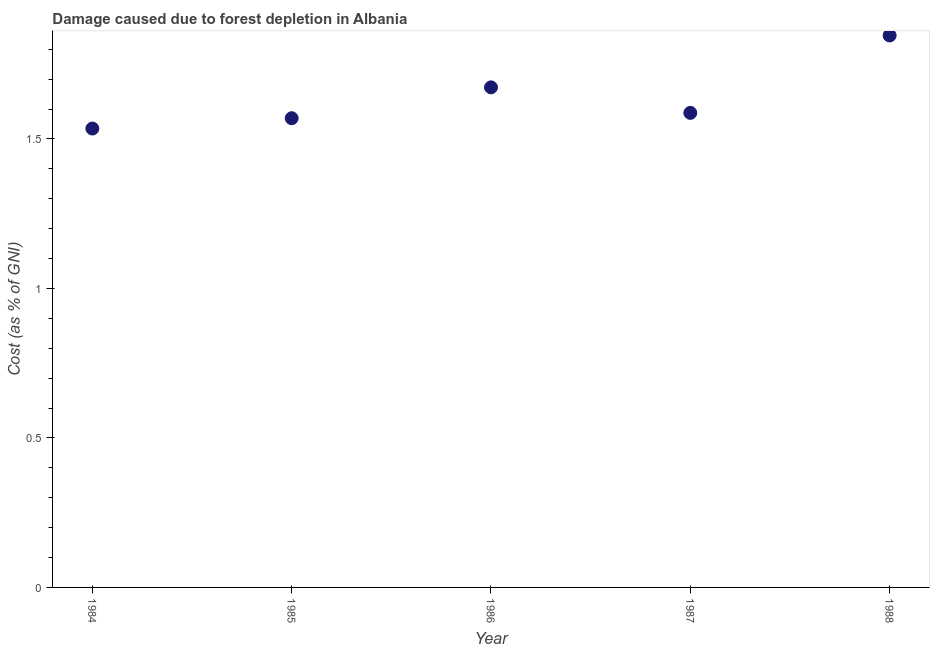What is the damage caused due to forest depletion in 1987?
Your answer should be very brief. 1.59. Across all years, what is the maximum damage caused due to forest depletion?
Offer a terse response. 1.85. Across all years, what is the minimum damage caused due to forest depletion?
Your answer should be compact. 1.53. What is the sum of the damage caused due to forest depletion?
Ensure brevity in your answer.  8.21. What is the difference between the damage caused due to forest depletion in 1985 and 1986?
Make the answer very short. -0.1. What is the average damage caused due to forest depletion per year?
Make the answer very short. 1.64. What is the median damage caused due to forest depletion?
Your answer should be compact. 1.59. Do a majority of the years between 1987 and 1988 (inclusive) have damage caused due to forest depletion greater than 0.7 %?
Keep it short and to the point. Yes. What is the ratio of the damage caused due to forest depletion in 1985 to that in 1988?
Ensure brevity in your answer.  0.85. Is the damage caused due to forest depletion in 1984 less than that in 1986?
Make the answer very short. Yes. What is the difference between the highest and the second highest damage caused due to forest depletion?
Provide a succinct answer. 0.17. What is the difference between the highest and the lowest damage caused due to forest depletion?
Offer a very short reply. 0.31. Does the damage caused due to forest depletion monotonically increase over the years?
Offer a very short reply. No. How many years are there in the graph?
Make the answer very short. 5. Are the values on the major ticks of Y-axis written in scientific E-notation?
Provide a succinct answer. No. Does the graph contain grids?
Keep it short and to the point. No. What is the title of the graph?
Keep it short and to the point. Damage caused due to forest depletion in Albania. What is the label or title of the X-axis?
Offer a very short reply. Year. What is the label or title of the Y-axis?
Give a very brief answer. Cost (as % of GNI). What is the Cost (as % of GNI) in 1984?
Offer a terse response. 1.53. What is the Cost (as % of GNI) in 1985?
Your response must be concise. 1.57. What is the Cost (as % of GNI) in 1986?
Ensure brevity in your answer.  1.67. What is the Cost (as % of GNI) in 1987?
Offer a very short reply. 1.59. What is the Cost (as % of GNI) in 1988?
Offer a very short reply. 1.85. What is the difference between the Cost (as % of GNI) in 1984 and 1985?
Keep it short and to the point. -0.03. What is the difference between the Cost (as % of GNI) in 1984 and 1986?
Your answer should be very brief. -0.14. What is the difference between the Cost (as % of GNI) in 1984 and 1987?
Give a very brief answer. -0.05. What is the difference between the Cost (as % of GNI) in 1984 and 1988?
Give a very brief answer. -0.31. What is the difference between the Cost (as % of GNI) in 1985 and 1986?
Your response must be concise. -0.1. What is the difference between the Cost (as % of GNI) in 1985 and 1987?
Your answer should be very brief. -0.02. What is the difference between the Cost (as % of GNI) in 1985 and 1988?
Your answer should be very brief. -0.28. What is the difference between the Cost (as % of GNI) in 1986 and 1987?
Keep it short and to the point. 0.09. What is the difference between the Cost (as % of GNI) in 1986 and 1988?
Your answer should be compact. -0.17. What is the difference between the Cost (as % of GNI) in 1987 and 1988?
Keep it short and to the point. -0.26. What is the ratio of the Cost (as % of GNI) in 1984 to that in 1985?
Provide a succinct answer. 0.98. What is the ratio of the Cost (as % of GNI) in 1984 to that in 1986?
Your answer should be compact. 0.92. What is the ratio of the Cost (as % of GNI) in 1984 to that in 1987?
Your response must be concise. 0.97. What is the ratio of the Cost (as % of GNI) in 1984 to that in 1988?
Your answer should be very brief. 0.83. What is the ratio of the Cost (as % of GNI) in 1985 to that in 1986?
Your answer should be very brief. 0.94. What is the ratio of the Cost (as % of GNI) in 1986 to that in 1987?
Your response must be concise. 1.05. What is the ratio of the Cost (as % of GNI) in 1986 to that in 1988?
Your response must be concise. 0.91. What is the ratio of the Cost (as % of GNI) in 1987 to that in 1988?
Your answer should be very brief. 0.86. 